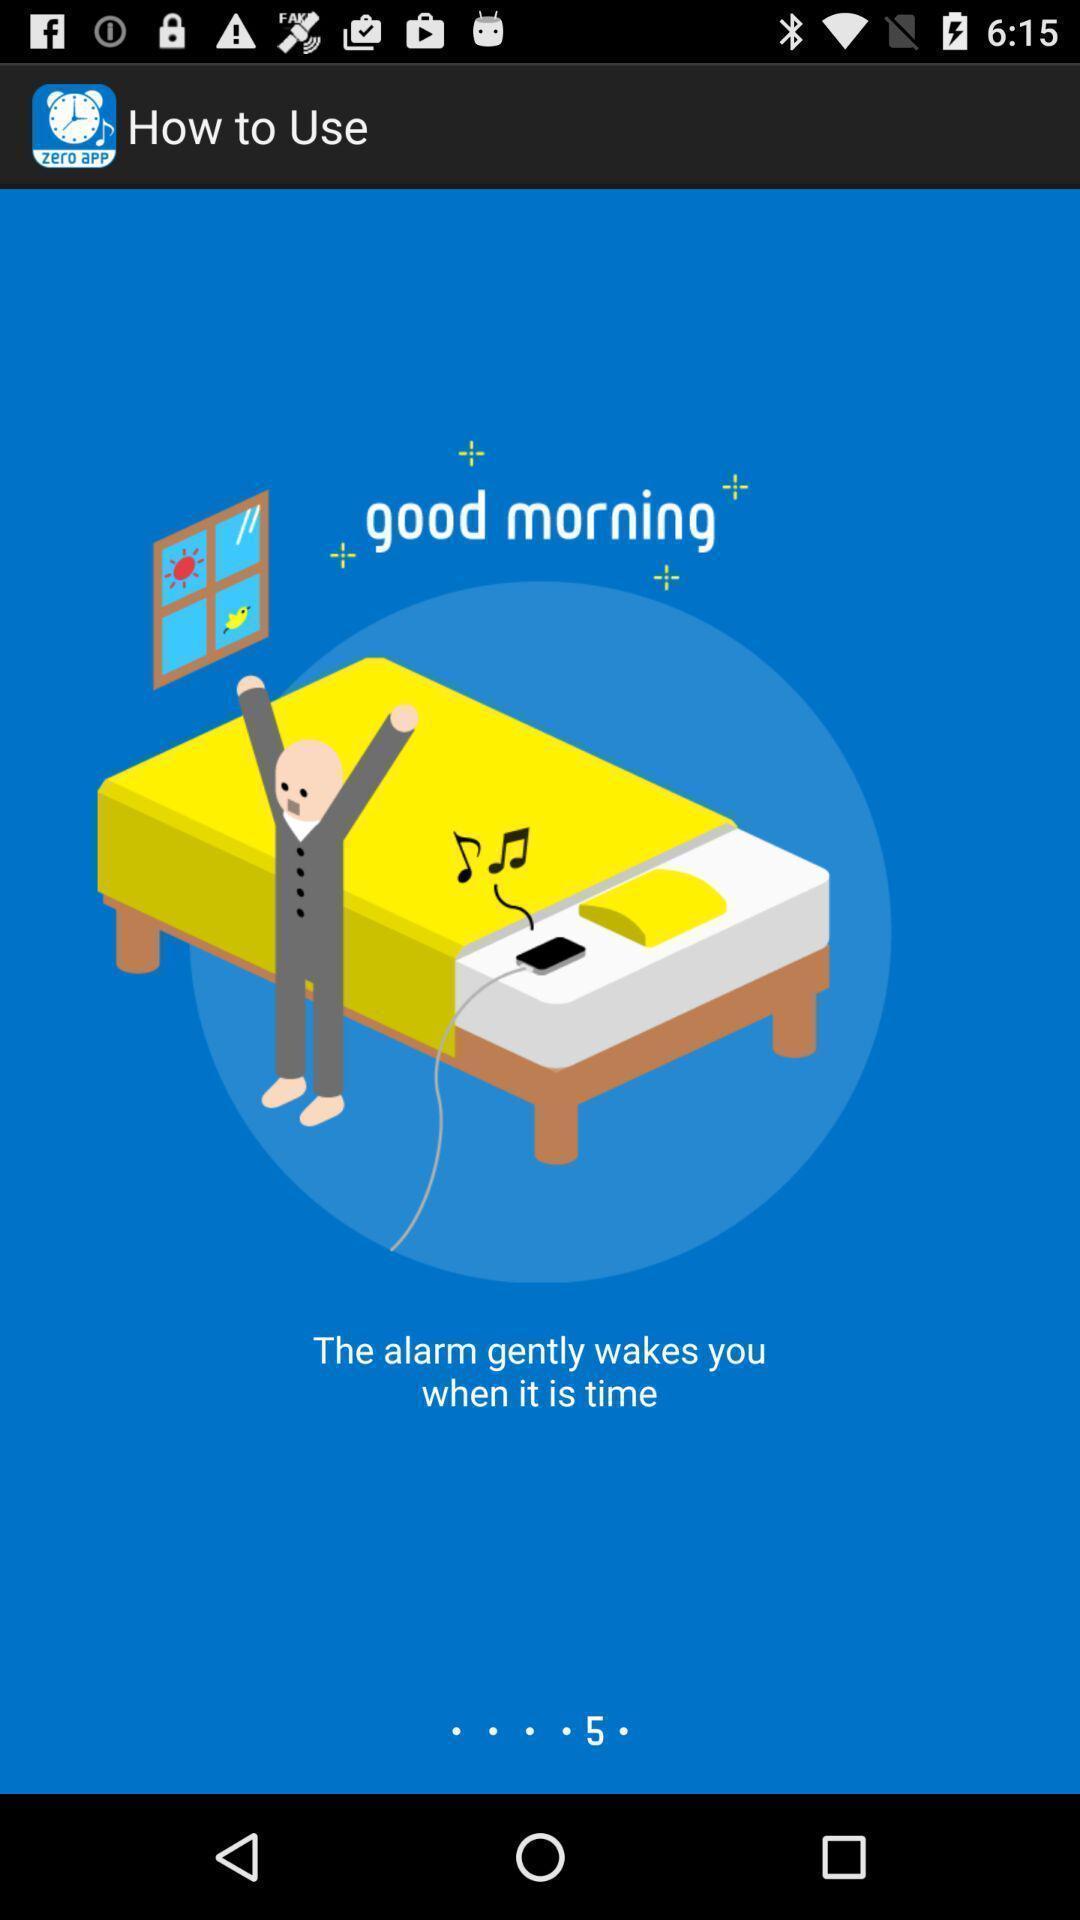Summarize the main components in this picture. Screen shows how to use settings of an alarm application. 